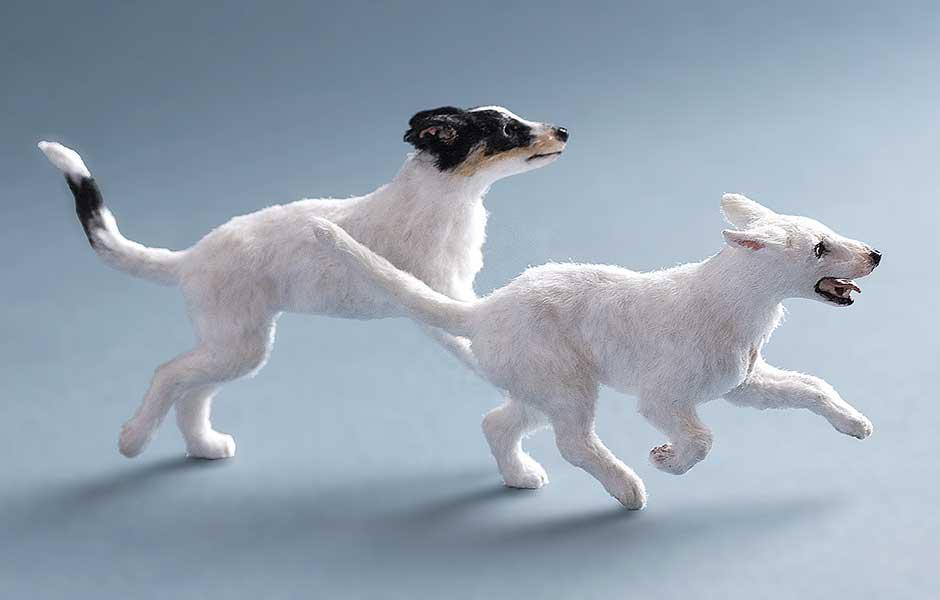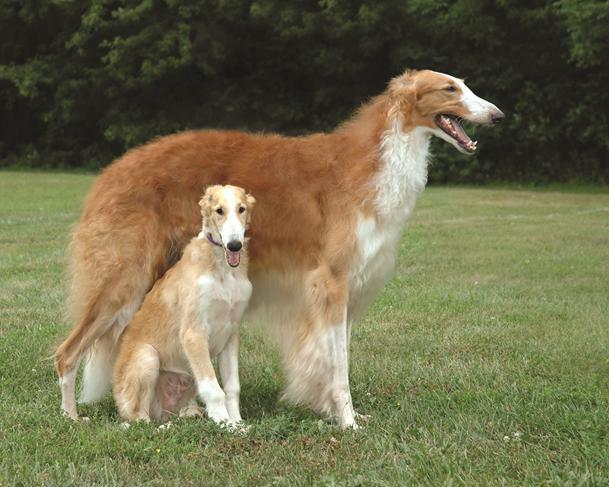The first image is the image on the left, the second image is the image on the right. Considering the images on both sides, is "There are at most two dogs." valid? Answer yes or no. No. The first image is the image on the left, the second image is the image on the right. For the images shown, is this caption "At least one of the dogs is near a body of water." true? Answer yes or no. No. 